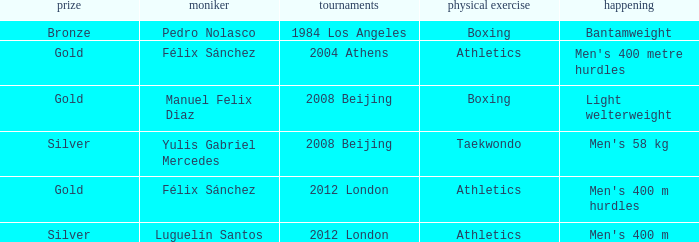Which Medal had a Games of 2008 beijing, and a Sport of taekwondo? Silver. 